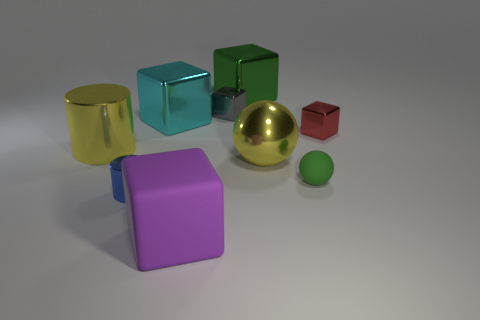Can you describe the biggest object and its color? The biggest object in the image is a sphere with a smooth and reflective surface, and it has a gold color. 